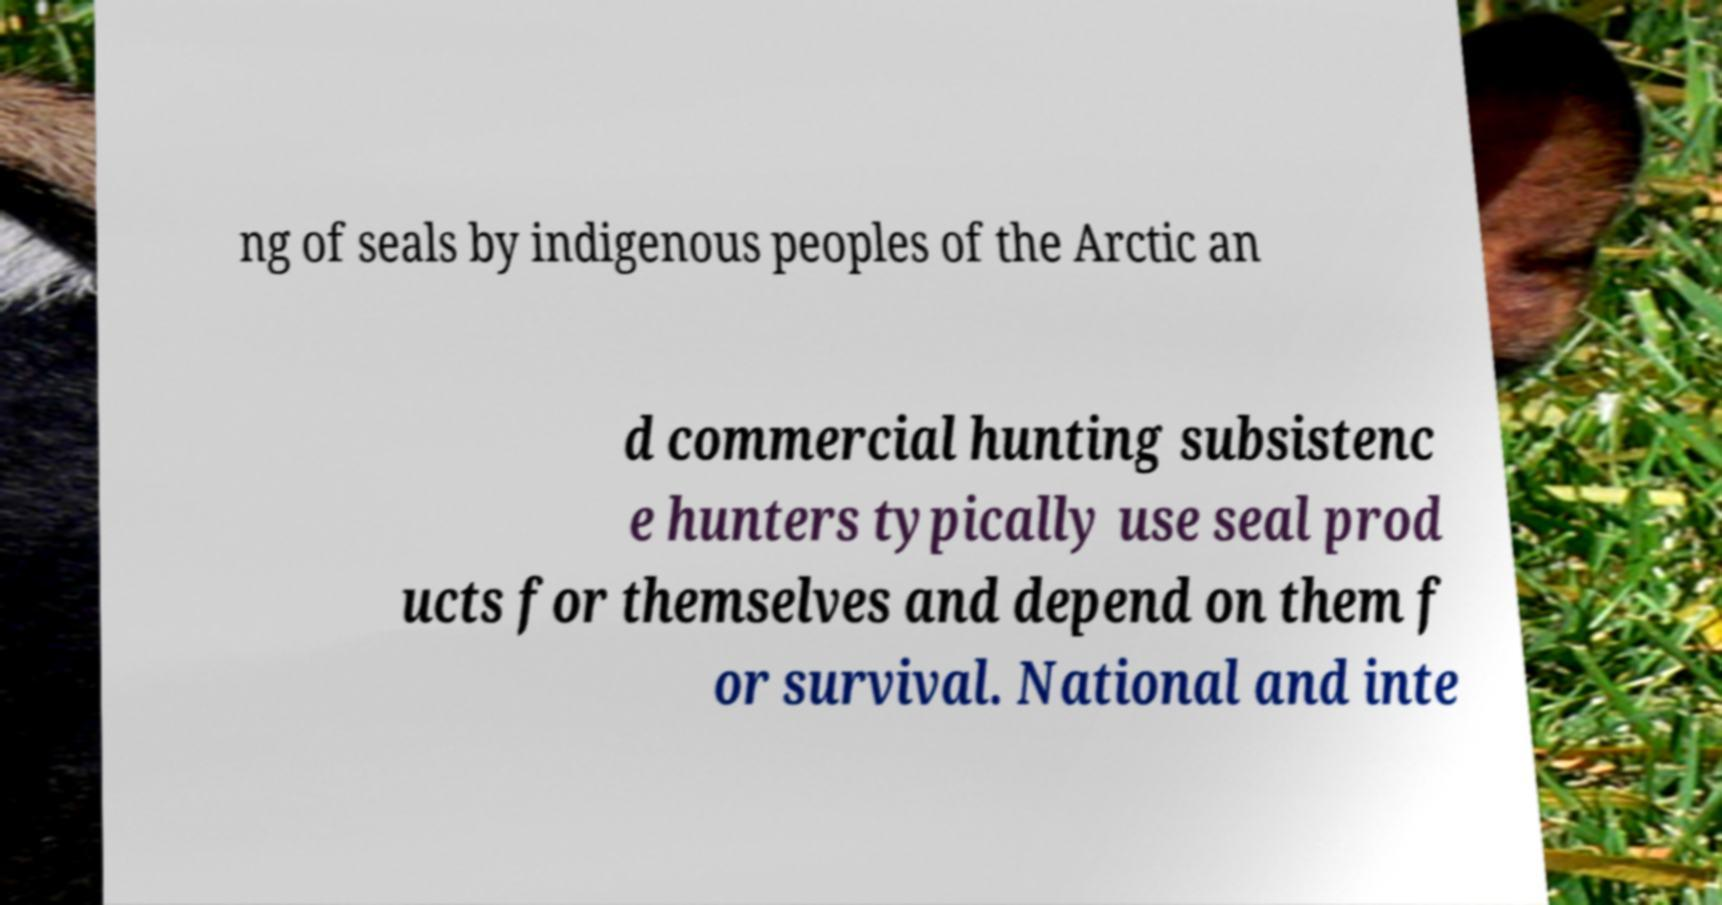Can you accurately transcribe the text from the provided image for me? ng of seals by indigenous peoples of the Arctic an d commercial hunting subsistenc e hunters typically use seal prod ucts for themselves and depend on them f or survival. National and inte 